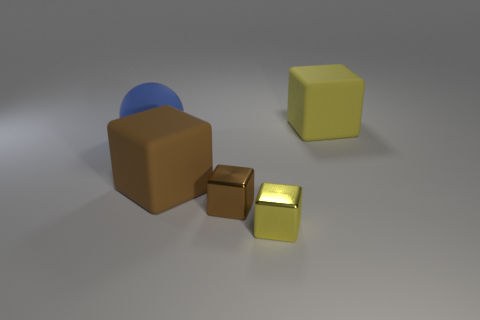Subtract all brown blocks. How many were subtracted if there are1brown blocks left? 1 Subtract all small brown cubes. How many cubes are left? 3 Subtract all yellow blocks. How many blocks are left? 2 Add 3 tiny metal cubes. How many objects exist? 8 Subtract all metal objects. Subtract all blue spheres. How many objects are left? 2 Add 5 blue rubber spheres. How many blue rubber spheres are left? 6 Add 3 yellow rubber cubes. How many yellow rubber cubes exist? 4 Subtract 0 blue blocks. How many objects are left? 5 Subtract all spheres. How many objects are left? 4 Subtract 1 spheres. How many spheres are left? 0 